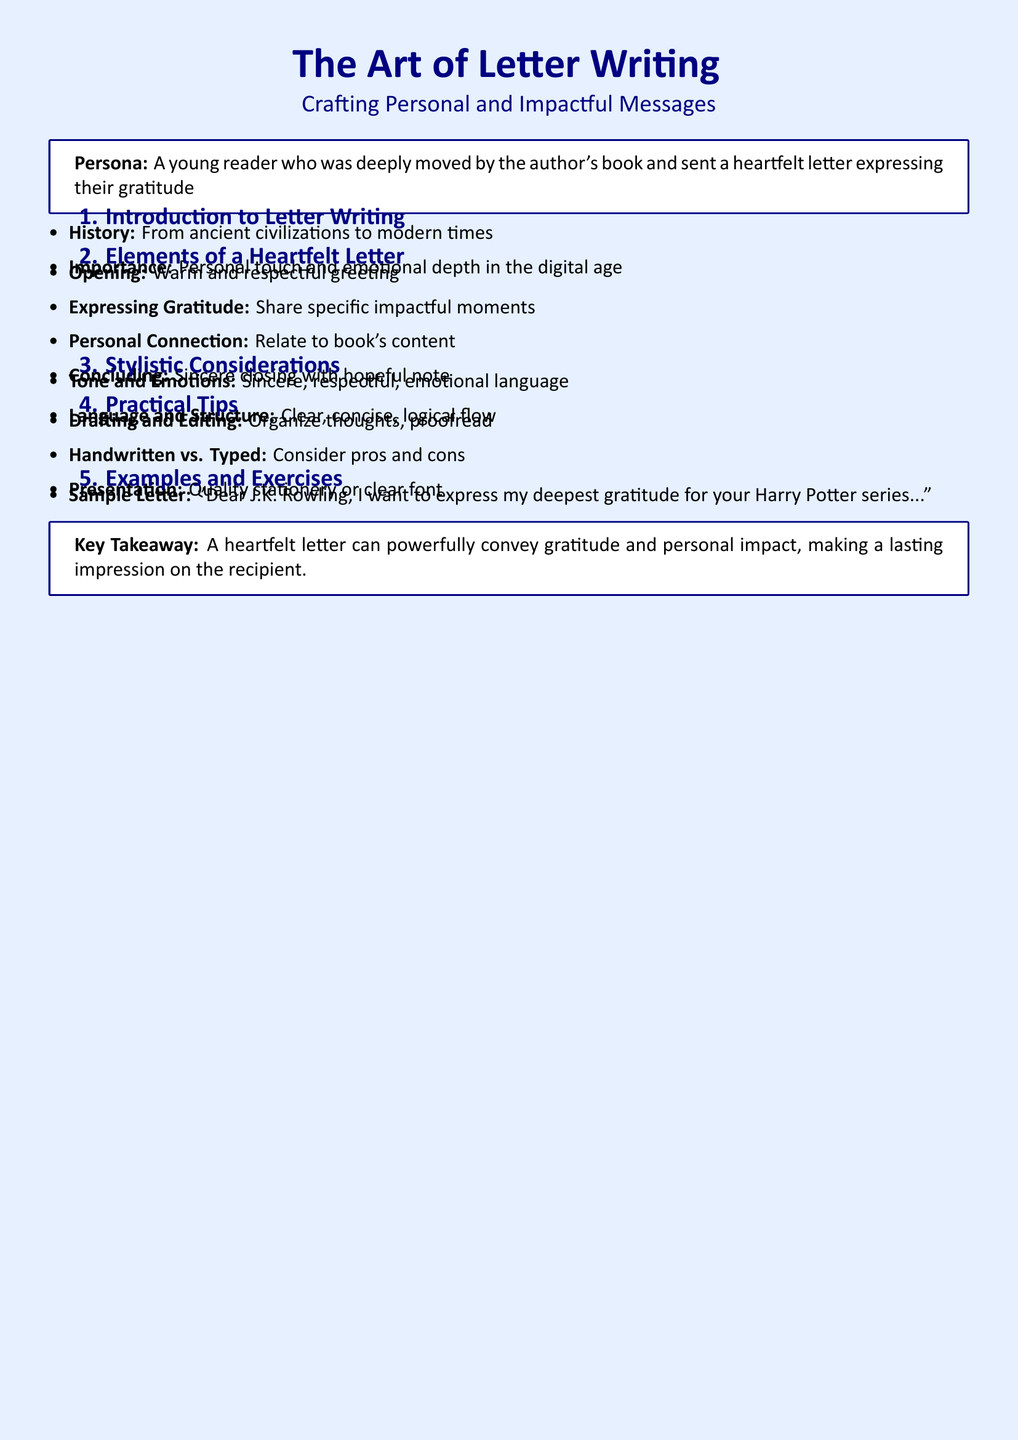What is the main title of the document? The main title is stated at the top of the document and introduces the subject.
Answer: The Art of Letter Writing What is the persona described in the document? The persona gives context for the lesson and is specified in a tcolorbox.
Answer: A young reader who was deeply moved by the author's book and sent a heartfelt letter expressing their gratitude What is the total number of sections in the lesson plan? The sections are numbered in the document, and this is calculated from the visible sections.
Answer: 5 What is the first element of a heartfelt letter according to the document? The document lists elements in a comprehensive format.
Answer: Opening What is one practical tip mentioned for letter writing? The tips in the section provide guidelines for effective letter writing.
Answer: Drafting and Editing What type of language should be used in a heartfelt letter? The stylistic considerations indicate the type of language to be employed.
Answer: Sincere, respectful, emotional language Who is mentioned in the sample letter example? The sample letter indicates a specific author as the recipient.
Answer: J.K. Rowling What is the purpose of the writing exercise suggested? The exercise is designed to engage the reader in practical application of the lesson content.
Answer: To write to a favorite author 